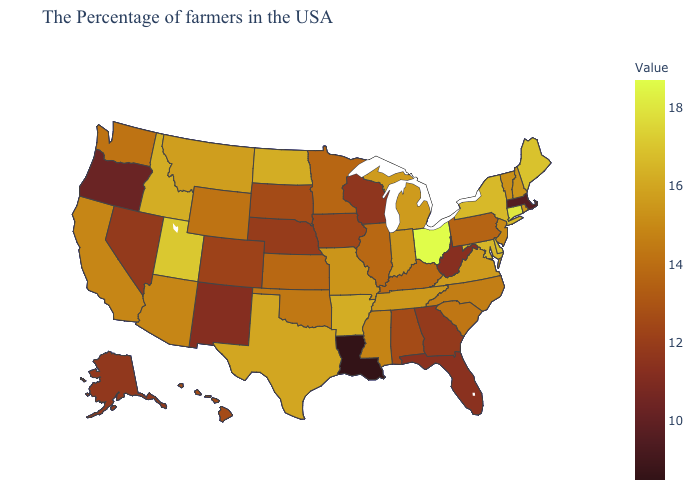Among the states that border Arizona , which have the highest value?
Give a very brief answer. Utah. Does Kansas have a lower value than Alabama?
Write a very short answer. No. Which states have the lowest value in the West?
Give a very brief answer. Oregon. Among the states that border Maryland , which have the lowest value?
Quick response, please. West Virginia. Does Utah have the highest value in the West?
Keep it brief. Yes. 